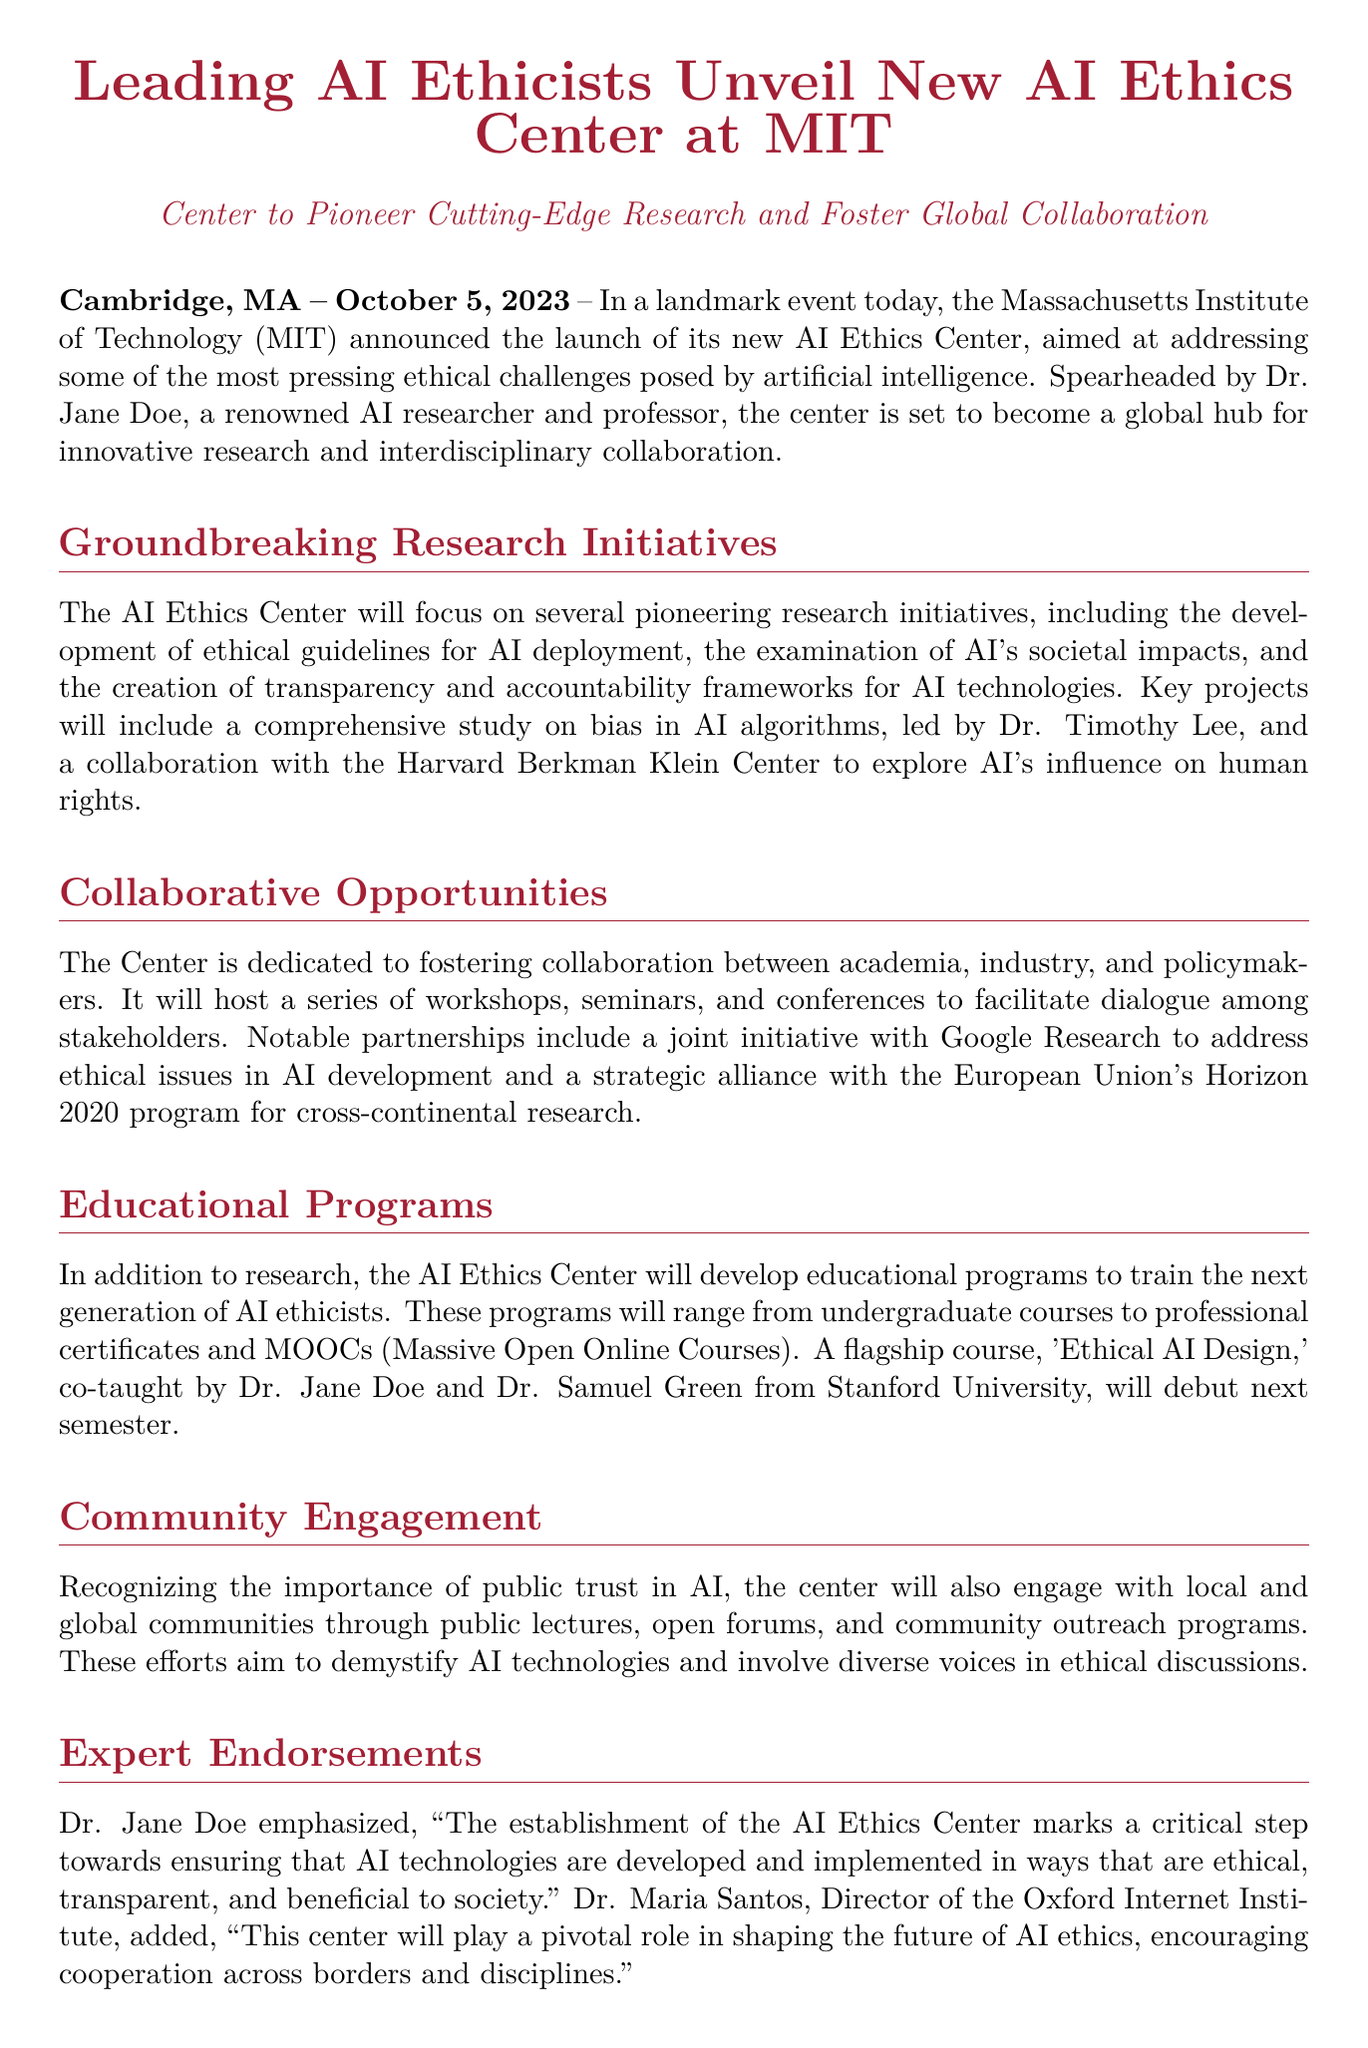What is the name of the new center? The document states that the new center is called the AI Ethics Center.
Answer: AI Ethics Center Who is the leader of the AI Ethics Center? The document identifies Dr. Jane Doe as the spearhead of the center.
Answer: Dr. Jane Doe When was the AI Ethics Center launched? According to the press release, the center was announced on October 5, 2023.
Answer: October 5, 2023 What key project will Dr. Timothy Lee lead? The document mentions that Dr. Timothy Lee will lead a study on bias in AI algorithms.
Answer: Study on bias in AI algorithms What type of courses will the AI Ethics Center develop? It states that the center will develop educational programs ranging from undergraduate courses to professional certificates and MOOCs.
Answer: Educational programs Which organization is partnering with the AI Ethics Center for research? The document lists a joint initiative with Google Research as a notable partnership.
Answer: Google Research What is the flagship course mentioned in the release? The document refers to 'Ethical AI Design' as the flagship course.
Answer: Ethical AI Design Who provided an endorsement for the center besides Dr. Jane Doe? The document includes an endorsement from Dr. Maria Santos, Director of the Oxford Internet Institute.
Answer: Dr. Maria Santos What is the primary goal of community engagement efforts by the center? The center aims to demystify AI technologies and involve diverse voices in ethical discussions.
Answer: Demystify AI technologies 